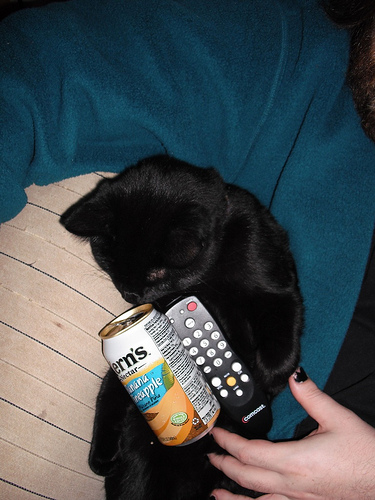<image>What is the cat sitting on? I don't know what the cat is sitting on. It can be a pillow, couch, sofa, remote, person, floor or chair. What is the cat sitting on? I am not sure what the cat is sitting on. It can be a pillow, couch, sofa, remote, person, floor, or chair. 